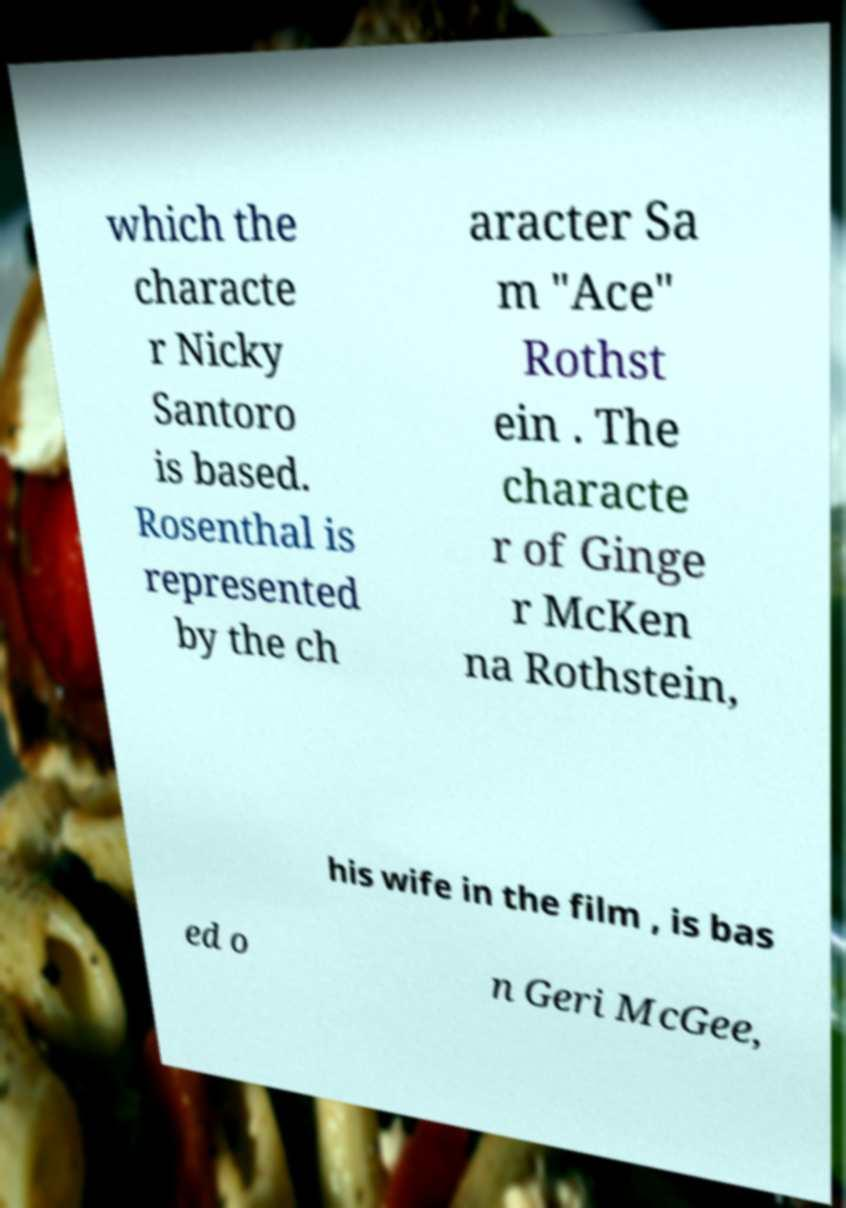Could you assist in decoding the text presented in this image and type it out clearly? which the characte r Nicky Santoro is based. Rosenthal is represented by the ch aracter Sa m "Ace" Rothst ein . The characte r of Ginge r McKen na Rothstein, his wife in the film , is bas ed o n Geri McGee, 